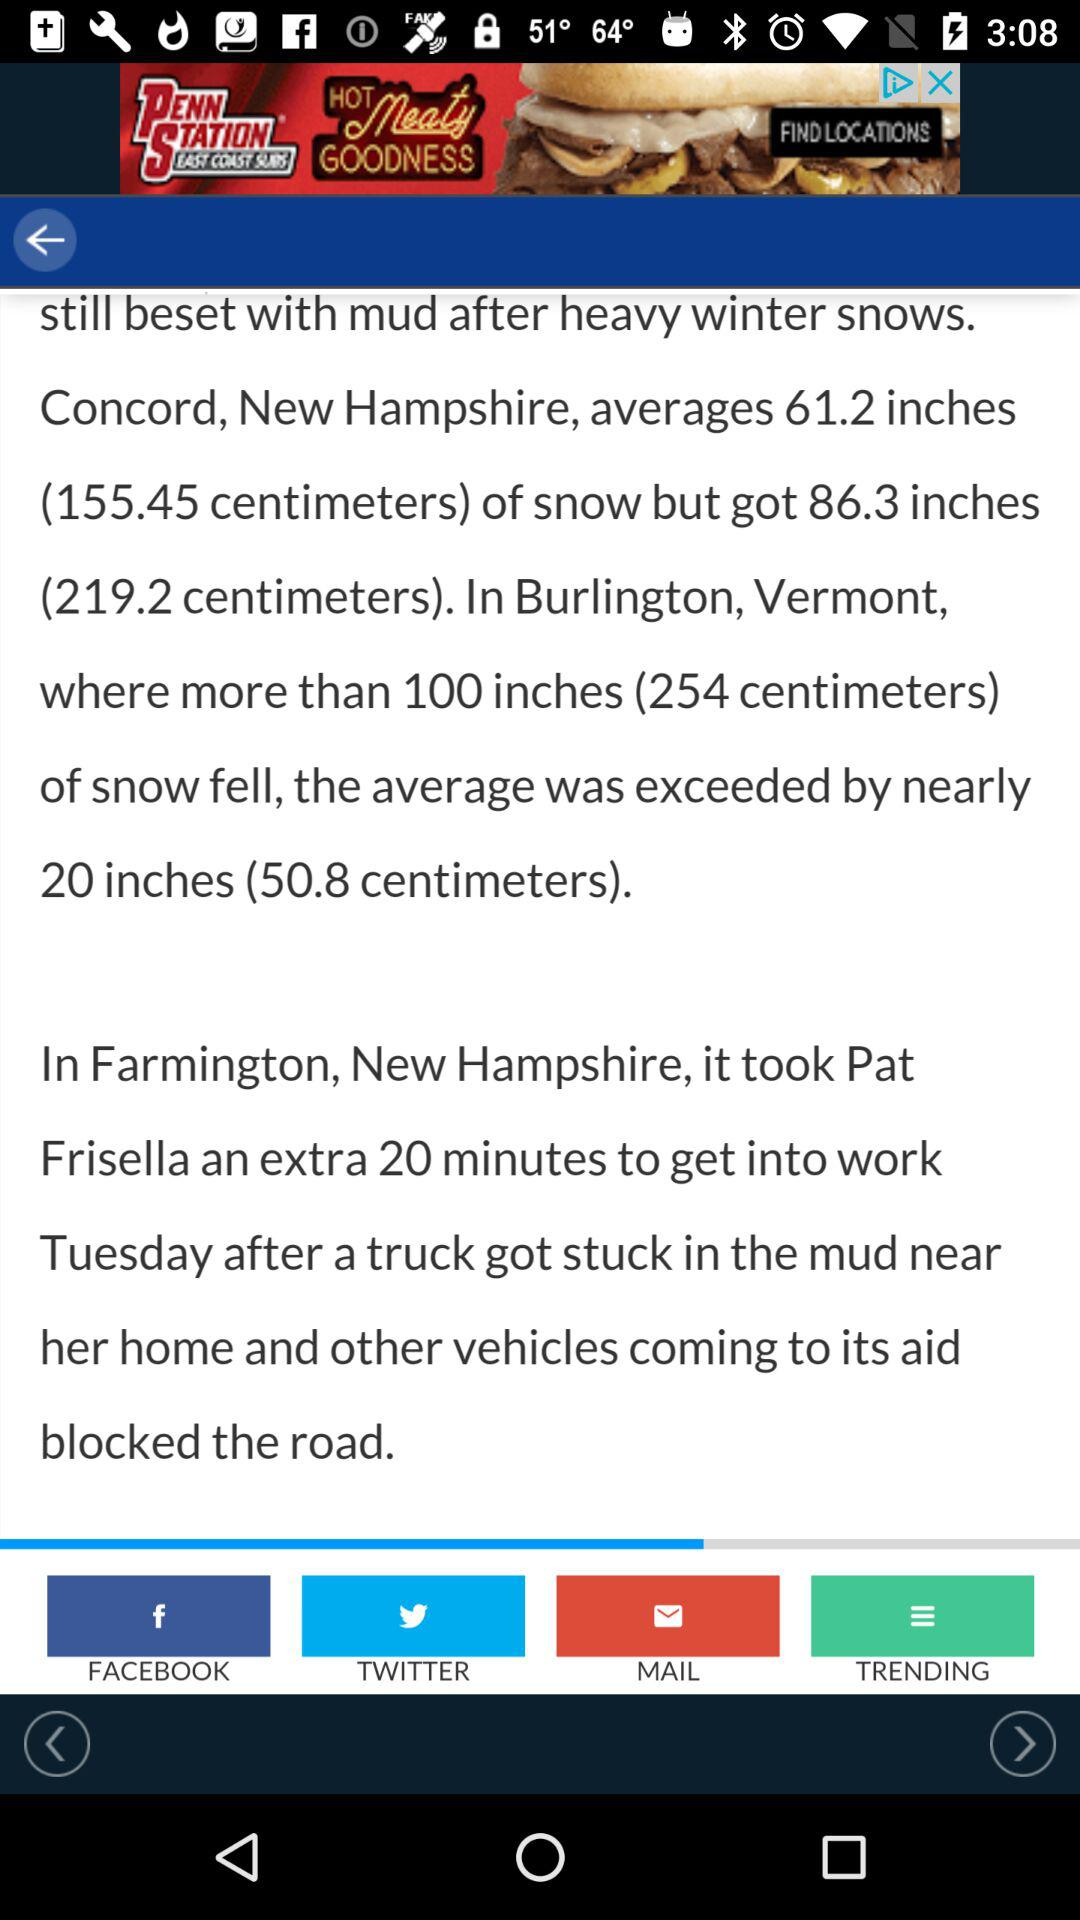How many degrees Fahrenheit is the difference between the current temperature and the dew point?
Answer the question using a single word or phrase. 24 